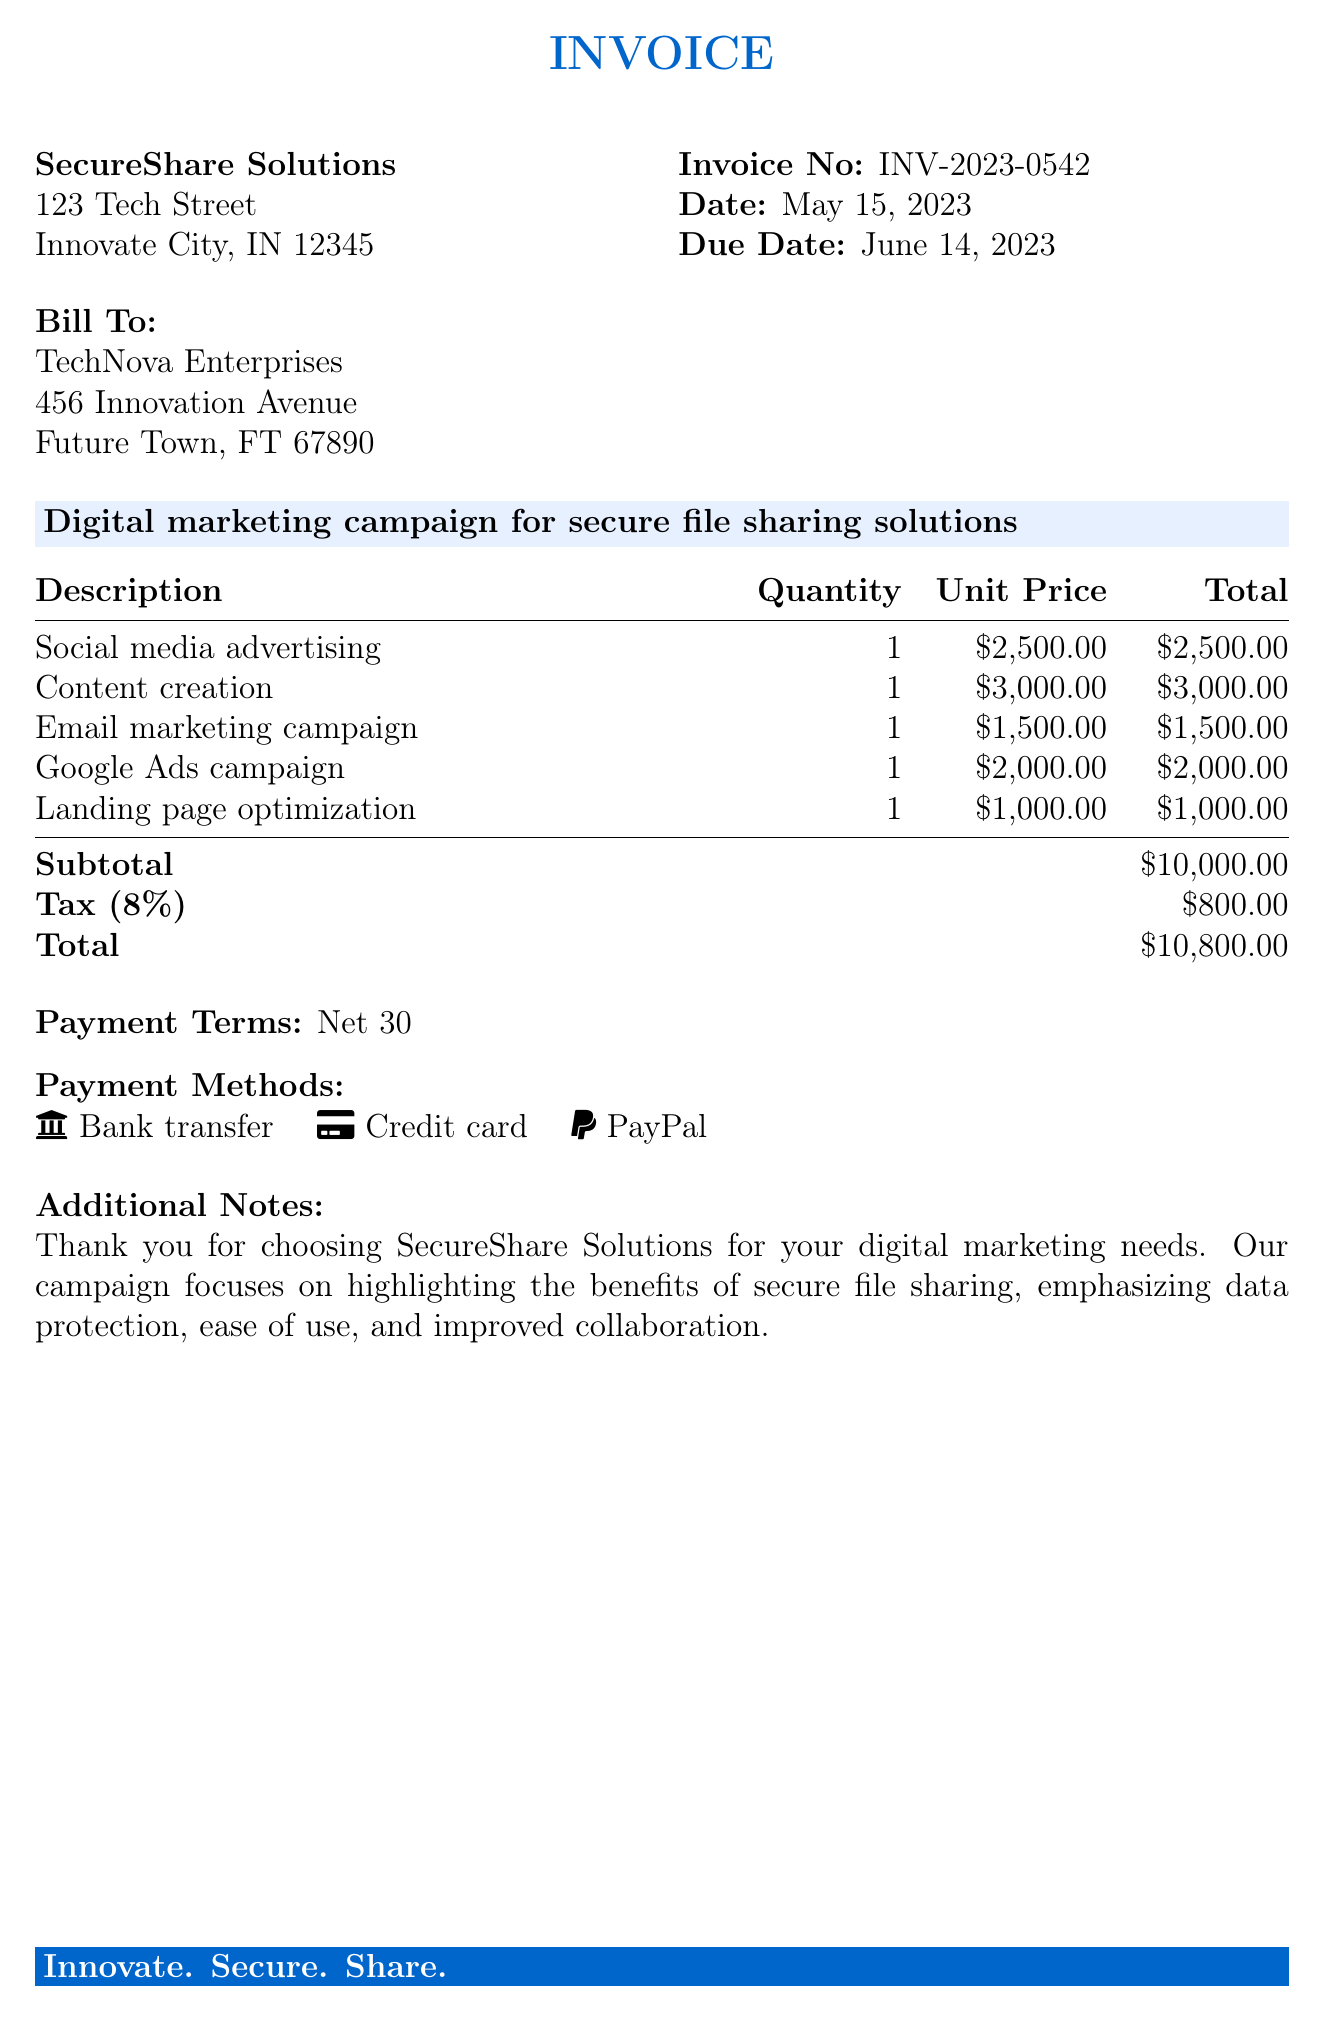What is the invoice number? The invoice number is a unique identifier for the bill, specified in the document.
Answer: INV-2023-0542 What is the due date? The due date indicates when the payment is expected to be made, found in the invoice.
Answer: June 14, 2023 What is the subtotal amount? The subtotal is the sum of all services before tax, as detailed in the document.
Answer: $10,000.00 How much is the tax? The tax amount is calculated based on the subtotal and is stated in the document.
Answer: $800.00 What is the total amount due? The total amount due incorporates both the subtotal and the tax, as shown in the invoice.
Answer: $10,800.00 Which company is being billed? The billed company is specified in the "Bill To" section of the invoice.
Answer: TechNova Enterprises What services are included in the digital marketing campaign? The services provided are listed in the services section of the document.
Answer: Social media advertising, Content creation, Email marketing campaign, Google Ads campaign, Landing page optimization What are the payment terms? The payment terms specify the time frame within which the payment must be made, mentioned in the invoice.
Answer: Net 30 What payment methods are accepted? The payment methods section outlines how payments can be made for the invoice, which is detailed in the document.
Answer: Bank transfer, Credit card, PayPal 